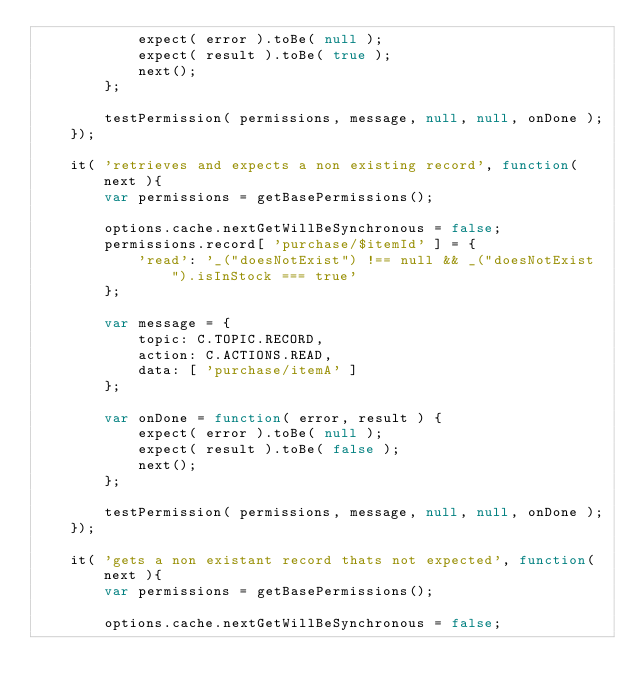Convert code to text. <code><loc_0><loc_0><loc_500><loc_500><_JavaScript_>			expect( error ).toBe( null );
			expect( result ).toBe( true );
			next();
		};

		testPermission( permissions, message, null, null, onDone );
	});

	it( 'retrieves and expects a non existing record', function( next ){
		var permissions = getBasePermissions();

		options.cache.nextGetWillBeSynchronous = false;
		permissions.record[ 'purchase/$itemId' ] = {
			'read': '_("doesNotExist") !== null && _("doesNotExist").isInStock === true'
		};

		var message = {
			topic: C.TOPIC.RECORD,
			action: C.ACTIONS.READ,
			data: [ 'purchase/itemA' ]
		};

		var onDone = function( error, result ) {
			expect( error ).toBe( null );
			expect( result ).toBe( false );
			next();
		};

		testPermission( permissions, message, null, null, onDone );
	});

	it( 'gets a non existant record thats not expected', function( next ){
		var permissions = getBasePermissions();

		options.cache.nextGetWillBeSynchronous = false;</code> 